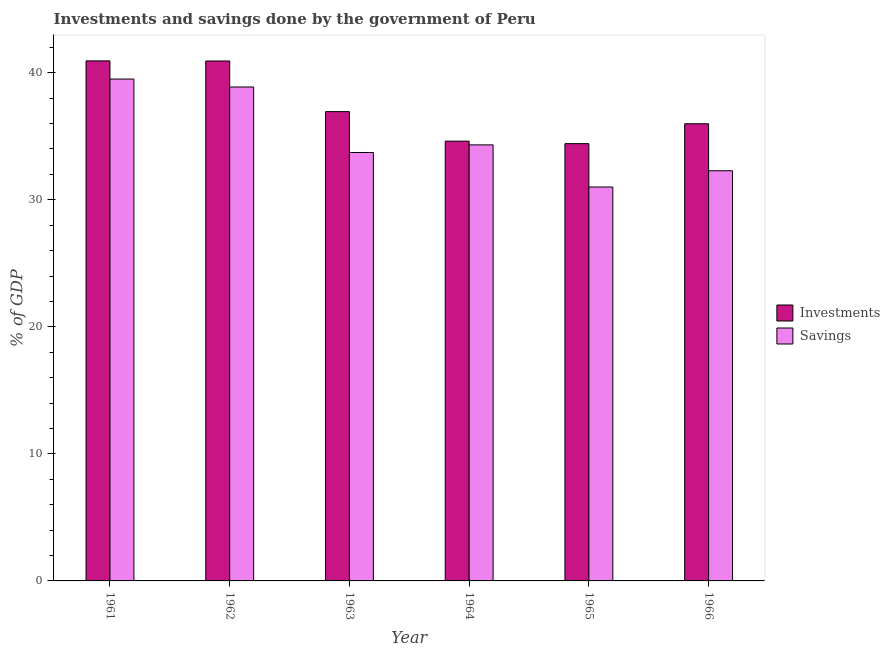How many different coloured bars are there?
Ensure brevity in your answer.  2. How many groups of bars are there?
Make the answer very short. 6. Are the number of bars on each tick of the X-axis equal?
Offer a very short reply. Yes. How many bars are there on the 6th tick from the left?
Your response must be concise. 2. What is the label of the 3rd group of bars from the left?
Provide a succinct answer. 1963. In how many cases, is the number of bars for a given year not equal to the number of legend labels?
Your answer should be compact. 0. What is the savings of government in 1966?
Provide a succinct answer. 32.29. Across all years, what is the maximum investments of government?
Your answer should be very brief. 40.94. Across all years, what is the minimum savings of government?
Give a very brief answer. 31.01. In which year was the savings of government minimum?
Offer a very short reply. 1965. What is the total savings of government in the graph?
Provide a short and direct response. 209.73. What is the difference between the investments of government in 1963 and that in 1965?
Offer a very short reply. 2.52. What is the difference between the savings of government in 1961 and the investments of government in 1963?
Give a very brief answer. 5.78. What is the average savings of government per year?
Your answer should be very brief. 34.96. In the year 1962, what is the difference between the investments of government and savings of government?
Keep it short and to the point. 0. In how many years, is the savings of government greater than 18 %?
Offer a terse response. 6. What is the ratio of the savings of government in 1963 to that in 1966?
Provide a short and direct response. 1.04. What is the difference between the highest and the second highest investments of government?
Offer a very short reply. 0.01. What is the difference between the highest and the lowest savings of government?
Provide a succinct answer. 8.5. Is the sum of the investments of government in 1961 and 1966 greater than the maximum savings of government across all years?
Ensure brevity in your answer.  Yes. What does the 1st bar from the left in 1962 represents?
Your response must be concise. Investments. What does the 2nd bar from the right in 1963 represents?
Your answer should be very brief. Investments. How many bars are there?
Your answer should be very brief. 12. Are all the bars in the graph horizontal?
Ensure brevity in your answer.  No. Does the graph contain any zero values?
Ensure brevity in your answer.  No. Does the graph contain grids?
Make the answer very short. No. How many legend labels are there?
Your answer should be very brief. 2. How are the legend labels stacked?
Provide a short and direct response. Vertical. What is the title of the graph?
Make the answer very short. Investments and savings done by the government of Peru. Does "US$" appear as one of the legend labels in the graph?
Ensure brevity in your answer.  No. What is the label or title of the Y-axis?
Ensure brevity in your answer.  % of GDP. What is the % of GDP in Investments in 1961?
Your answer should be very brief. 40.94. What is the % of GDP of Savings in 1961?
Offer a very short reply. 39.51. What is the % of GDP of Investments in 1962?
Offer a very short reply. 40.93. What is the % of GDP of Savings in 1962?
Provide a short and direct response. 38.88. What is the % of GDP in Investments in 1963?
Make the answer very short. 36.94. What is the % of GDP of Savings in 1963?
Offer a very short reply. 33.73. What is the % of GDP of Investments in 1964?
Make the answer very short. 34.62. What is the % of GDP of Savings in 1964?
Provide a short and direct response. 34.32. What is the % of GDP of Investments in 1965?
Provide a succinct answer. 34.42. What is the % of GDP in Savings in 1965?
Give a very brief answer. 31.01. What is the % of GDP of Investments in 1966?
Make the answer very short. 35.99. What is the % of GDP of Savings in 1966?
Make the answer very short. 32.29. Across all years, what is the maximum % of GDP in Investments?
Offer a very short reply. 40.94. Across all years, what is the maximum % of GDP of Savings?
Keep it short and to the point. 39.51. Across all years, what is the minimum % of GDP of Investments?
Your answer should be compact. 34.42. Across all years, what is the minimum % of GDP of Savings?
Your answer should be compact. 31.01. What is the total % of GDP of Investments in the graph?
Offer a terse response. 223.83. What is the total % of GDP of Savings in the graph?
Keep it short and to the point. 209.73. What is the difference between the % of GDP in Investments in 1961 and that in 1962?
Offer a very short reply. 0.01. What is the difference between the % of GDP in Savings in 1961 and that in 1962?
Make the answer very short. 0.63. What is the difference between the % of GDP of Investments in 1961 and that in 1963?
Provide a short and direct response. 3.99. What is the difference between the % of GDP of Savings in 1961 and that in 1963?
Keep it short and to the point. 5.78. What is the difference between the % of GDP of Investments in 1961 and that in 1964?
Your answer should be compact. 6.32. What is the difference between the % of GDP of Savings in 1961 and that in 1964?
Give a very brief answer. 5.18. What is the difference between the % of GDP of Investments in 1961 and that in 1965?
Give a very brief answer. 6.52. What is the difference between the % of GDP in Savings in 1961 and that in 1965?
Your answer should be compact. 8.5. What is the difference between the % of GDP in Investments in 1961 and that in 1966?
Your response must be concise. 4.95. What is the difference between the % of GDP of Savings in 1961 and that in 1966?
Provide a short and direct response. 7.22. What is the difference between the % of GDP in Investments in 1962 and that in 1963?
Ensure brevity in your answer.  3.99. What is the difference between the % of GDP of Savings in 1962 and that in 1963?
Keep it short and to the point. 5.16. What is the difference between the % of GDP of Investments in 1962 and that in 1964?
Offer a very short reply. 6.31. What is the difference between the % of GDP in Savings in 1962 and that in 1964?
Your answer should be compact. 4.56. What is the difference between the % of GDP of Investments in 1962 and that in 1965?
Provide a short and direct response. 6.51. What is the difference between the % of GDP of Savings in 1962 and that in 1965?
Keep it short and to the point. 7.87. What is the difference between the % of GDP of Investments in 1962 and that in 1966?
Your answer should be compact. 4.94. What is the difference between the % of GDP of Savings in 1962 and that in 1966?
Your answer should be very brief. 6.59. What is the difference between the % of GDP of Investments in 1963 and that in 1964?
Your answer should be compact. 2.32. What is the difference between the % of GDP of Savings in 1963 and that in 1964?
Give a very brief answer. -0.6. What is the difference between the % of GDP in Investments in 1963 and that in 1965?
Your answer should be compact. 2.52. What is the difference between the % of GDP in Savings in 1963 and that in 1965?
Offer a very short reply. 2.72. What is the difference between the % of GDP in Investments in 1963 and that in 1966?
Provide a short and direct response. 0.96. What is the difference between the % of GDP of Savings in 1963 and that in 1966?
Ensure brevity in your answer.  1.44. What is the difference between the % of GDP of Investments in 1964 and that in 1965?
Give a very brief answer. 0.2. What is the difference between the % of GDP in Savings in 1964 and that in 1965?
Keep it short and to the point. 3.32. What is the difference between the % of GDP in Investments in 1964 and that in 1966?
Offer a very short reply. -1.37. What is the difference between the % of GDP of Savings in 1964 and that in 1966?
Make the answer very short. 2.04. What is the difference between the % of GDP in Investments in 1965 and that in 1966?
Keep it short and to the point. -1.57. What is the difference between the % of GDP in Savings in 1965 and that in 1966?
Make the answer very short. -1.28. What is the difference between the % of GDP of Investments in 1961 and the % of GDP of Savings in 1962?
Provide a short and direct response. 2.06. What is the difference between the % of GDP in Investments in 1961 and the % of GDP in Savings in 1963?
Your answer should be very brief. 7.21. What is the difference between the % of GDP of Investments in 1961 and the % of GDP of Savings in 1964?
Your answer should be compact. 6.61. What is the difference between the % of GDP of Investments in 1961 and the % of GDP of Savings in 1965?
Your answer should be very brief. 9.93. What is the difference between the % of GDP of Investments in 1961 and the % of GDP of Savings in 1966?
Offer a terse response. 8.65. What is the difference between the % of GDP of Investments in 1962 and the % of GDP of Savings in 1963?
Provide a succinct answer. 7.2. What is the difference between the % of GDP of Investments in 1962 and the % of GDP of Savings in 1964?
Ensure brevity in your answer.  6.6. What is the difference between the % of GDP in Investments in 1962 and the % of GDP in Savings in 1965?
Your answer should be very brief. 9.92. What is the difference between the % of GDP in Investments in 1962 and the % of GDP in Savings in 1966?
Offer a terse response. 8.64. What is the difference between the % of GDP of Investments in 1963 and the % of GDP of Savings in 1964?
Your answer should be compact. 2.62. What is the difference between the % of GDP in Investments in 1963 and the % of GDP in Savings in 1965?
Offer a very short reply. 5.93. What is the difference between the % of GDP in Investments in 1963 and the % of GDP in Savings in 1966?
Keep it short and to the point. 4.65. What is the difference between the % of GDP in Investments in 1964 and the % of GDP in Savings in 1965?
Keep it short and to the point. 3.61. What is the difference between the % of GDP in Investments in 1964 and the % of GDP in Savings in 1966?
Keep it short and to the point. 2.33. What is the difference between the % of GDP in Investments in 1965 and the % of GDP in Savings in 1966?
Your answer should be compact. 2.13. What is the average % of GDP in Investments per year?
Your answer should be very brief. 37.31. What is the average % of GDP in Savings per year?
Provide a short and direct response. 34.96. In the year 1961, what is the difference between the % of GDP in Investments and % of GDP in Savings?
Offer a terse response. 1.43. In the year 1962, what is the difference between the % of GDP in Investments and % of GDP in Savings?
Offer a terse response. 2.05. In the year 1963, what is the difference between the % of GDP in Investments and % of GDP in Savings?
Keep it short and to the point. 3.22. In the year 1964, what is the difference between the % of GDP in Investments and % of GDP in Savings?
Your answer should be compact. 0.29. In the year 1965, what is the difference between the % of GDP of Investments and % of GDP of Savings?
Your answer should be very brief. 3.41. In the year 1966, what is the difference between the % of GDP of Investments and % of GDP of Savings?
Give a very brief answer. 3.7. What is the ratio of the % of GDP in Savings in 1961 to that in 1962?
Keep it short and to the point. 1.02. What is the ratio of the % of GDP of Investments in 1961 to that in 1963?
Make the answer very short. 1.11. What is the ratio of the % of GDP in Savings in 1961 to that in 1963?
Offer a very short reply. 1.17. What is the ratio of the % of GDP of Investments in 1961 to that in 1964?
Offer a very short reply. 1.18. What is the ratio of the % of GDP in Savings in 1961 to that in 1964?
Offer a terse response. 1.15. What is the ratio of the % of GDP in Investments in 1961 to that in 1965?
Keep it short and to the point. 1.19. What is the ratio of the % of GDP of Savings in 1961 to that in 1965?
Ensure brevity in your answer.  1.27. What is the ratio of the % of GDP in Investments in 1961 to that in 1966?
Offer a terse response. 1.14. What is the ratio of the % of GDP of Savings in 1961 to that in 1966?
Give a very brief answer. 1.22. What is the ratio of the % of GDP of Investments in 1962 to that in 1963?
Your answer should be compact. 1.11. What is the ratio of the % of GDP of Savings in 1962 to that in 1963?
Keep it short and to the point. 1.15. What is the ratio of the % of GDP of Investments in 1962 to that in 1964?
Your response must be concise. 1.18. What is the ratio of the % of GDP in Savings in 1962 to that in 1964?
Provide a short and direct response. 1.13. What is the ratio of the % of GDP in Investments in 1962 to that in 1965?
Your response must be concise. 1.19. What is the ratio of the % of GDP of Savings in 1962 to that in 1965?
Offer a terse response. 1.25. What is the ratio of the % of GDP in Investments in 1962 to that in 1966?
Your answer should be compact. 1.14. What is the ratio of the % of GDP in Savings in 1962 to that in 1966?
Offer a terse response. 1.2. What is the ratio of the % of GDP in Investments in 1963 to that in 1964?
Give a very brief answer. 1.07. What is the ratio of the % of GDP of Savings in 1963 to that in 1964?
Give a very brief answer. 0.98. What is the ratio of the % of GDP of Investments in 1963 to that in 1965?
Offer a terse response. 1.07. What is the ratio of the % of GDP in Savings in 1963 to that in 1965?
Give a very brief answer. 1.09. What is the ratio of the % of GDP in Investments in 1963 to that in 1966?
Ensure brevity in your answer.  1.03. What is the ratio of the % of GDP of Savings in 1963 to that in 1966?
Make the answer very short. 1.04. What is the ratio of the % of GDP of Investments in 1964 to that in 1965?
Give a very brief answer. 1.01. What is the ratio of the % of GDP of Savings in 1964 to that in 1965?
Your response must be concise. 1.11. What is the ratio of the % of GDP in Investments in 1964 to that in 1966?
Make the answer very short. 0.96. What is the ratio of the % of GDP in Savings in 1964 to that in 1966?
Provide a short and direct response. 1.06. What is the ratio of the % of GDP of Investments in 1965 to that in 1966?
Provide a short and direct response. 0.96. What is the ratio of the % of GDP of Savings in 1965 to that in 1966?
Make the answer very short. 0.96. What is the difference between the highest and the second highest % of GDP of Investments?
Keep it short and to the point. 0.01. What is the difference between the highest and the second highest % of GDP of Savings?
Provide a short and direct response. 0.63. What is the difference between the highest and the lowest % of GDP in Investments?
Give a very brief answer. 6.52. What is the difference between the highest and the lowest % of GDP in Savings?
Ensure brevity in your answer.  8.5. 